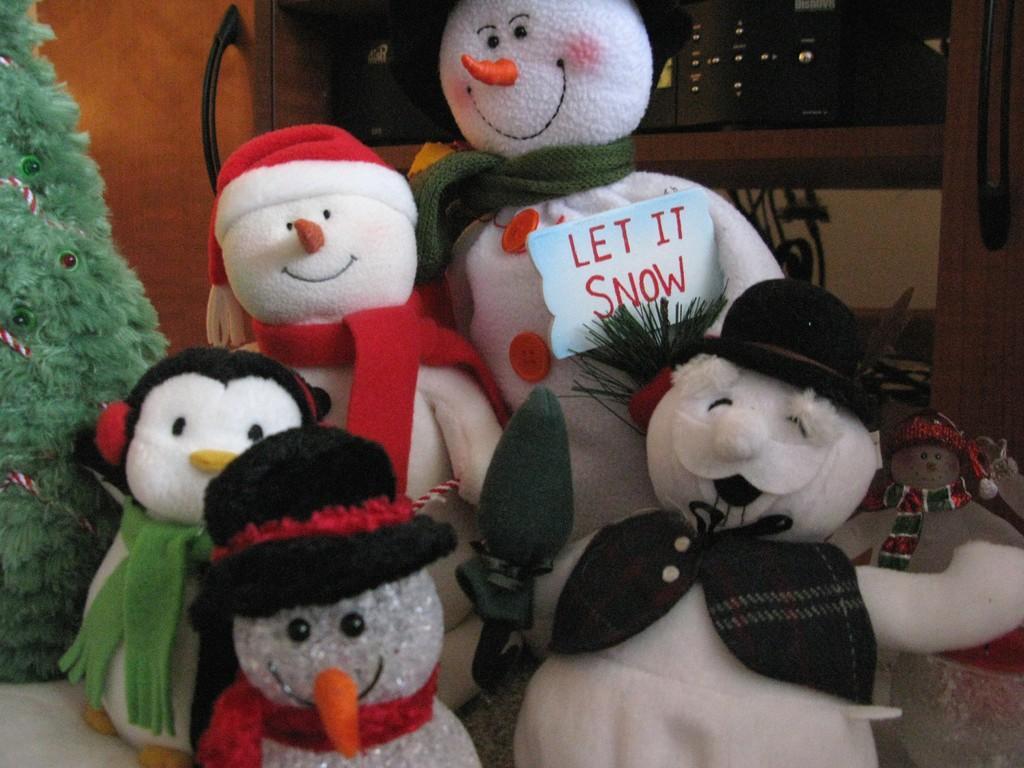Can you describe this image briefly? In this image we can see a group of dolls which are placed on the surface. We can also see a tree, a door, a board with some text on it and some devices in a shelf. 